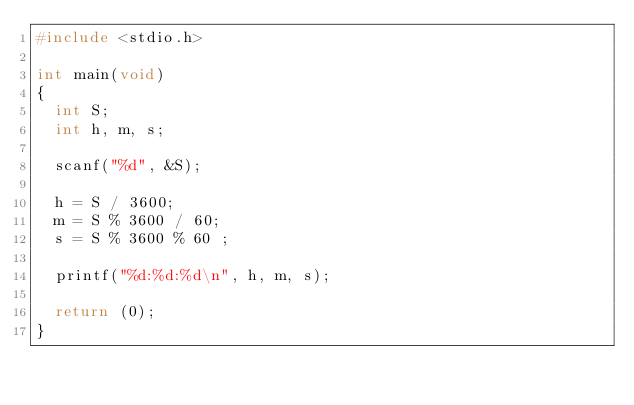<code> <loc_0><loc_0><loc_500><loc_500><_C_>#include <stdio.h>

int main(void)
{
	int S;
	int h, m, s;
	
	scanf("%d", &S);
	
	h = S / 3600;
	m = S % 3600 / 60;
	s = S % 3600 % 60 ;
	
	printf("%d:%d:%d\n", h, m, s);
	
	return (0);
}</code> 